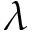Convert formula to latex. <formula><loc_0><loc_0><loc_500><loc_500>\lambda</formula> 